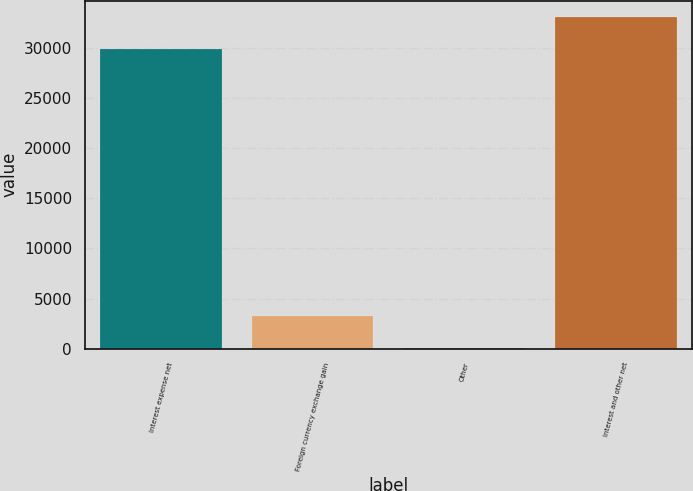Convert chart to OTSL. <chart><loc_0><loc_0><loc_500><loc_500><bar_chart><fcel>Interest expense net<fcel>Foreign currency exchange gain<fcel>Other<fcel>Interest and other net<nl><fcel>29901<fcel>3257.7<fcel>76<fcel>33082.7<nl></chart> 